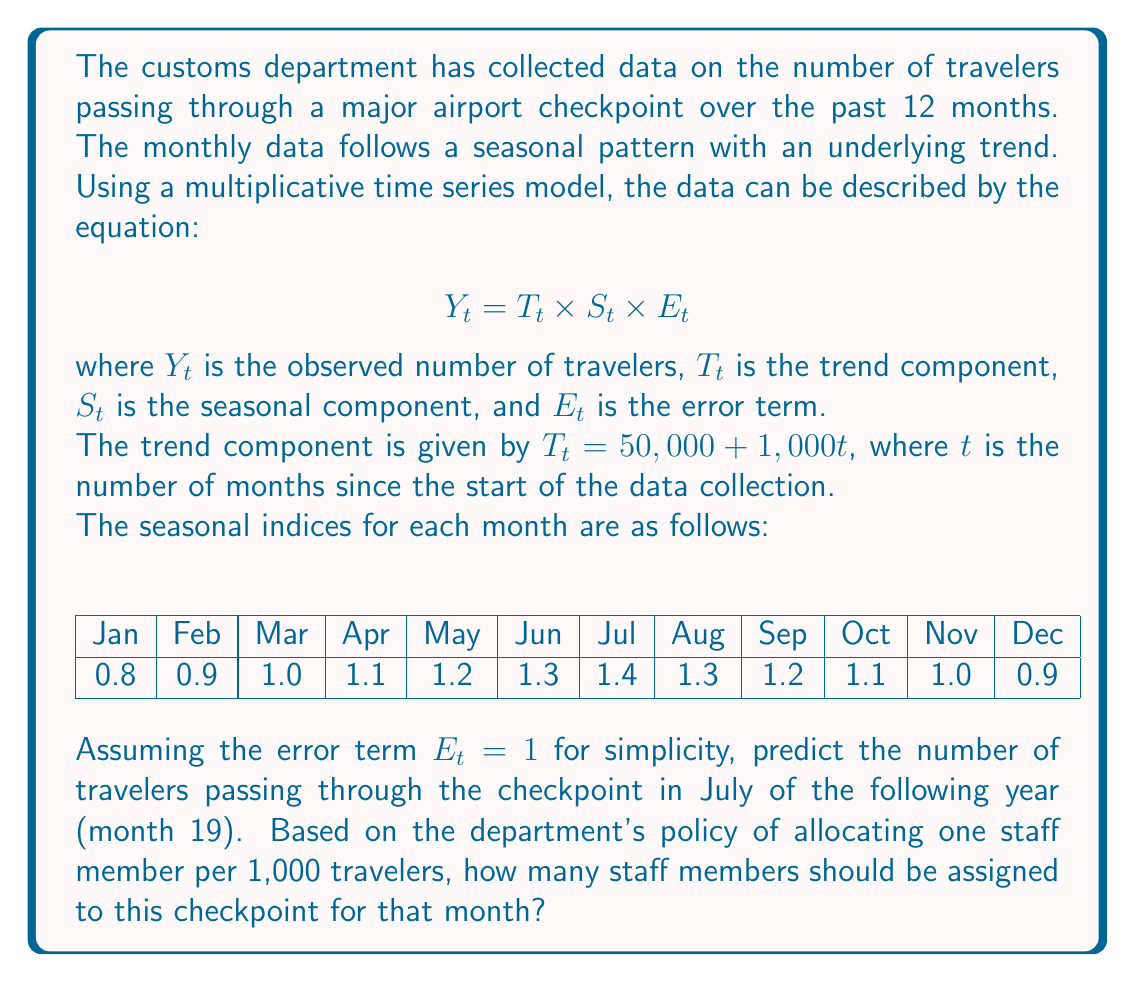What is the answer to this math problem? To solve this problem, we need to follow these steps:

1. Calculate the trend component $T_t$ for month 19 (July of the following year):
   $T_{19} = 50,000 + 1,000 \times 19 = 69,000$

2. Identify the seasonal index $S_t$ for July:
   $S_{\text{July}} = 1.4$

3. Calculate the predicted number of travelers $Y_{19}$ using the multiplicative model:
   $Y_{19} = T_{19} \times S_{\text{July}} \times E_{19}$
   $Y_{19} = 69,000 \times 1.4 \times 1 = 96,600$

4. Determine the number of staff members needed based on the policy:
   Staff members = $\frac{\text{Number of travelers}}{1,000}$
   Staff members = $\frac{96,600}{1,000} = 96.6$

Since we can't allocate a fractional number of staff members, we round up to the nearest whole number to ensure adequate staffing.
Answer: The predicted number of travelers passing through the checkpoint in July of the following year is 96,600. Based on the department's staffing policy, 97 staff members should be assigned to this checkpoint for that month. 